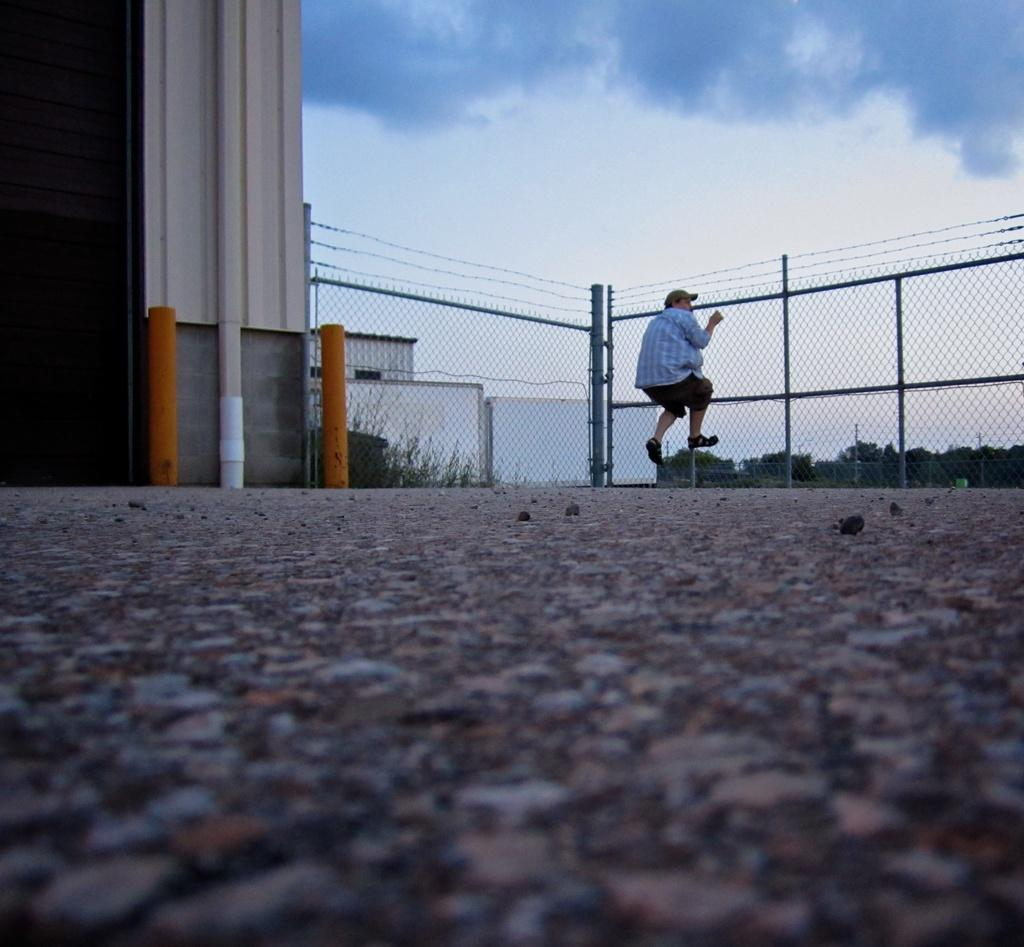What is the man in the image doing? The man is climbing the fence in the image. What can be seen in the background of the image? Buildings, trees, and street poles are visible in the image. What is visible in the sky in the image? The sky is visible in the image, and clouds are present. What is the weight of the brothers in the image? There are no brothers present in the image, so their weight cannot be determined. 